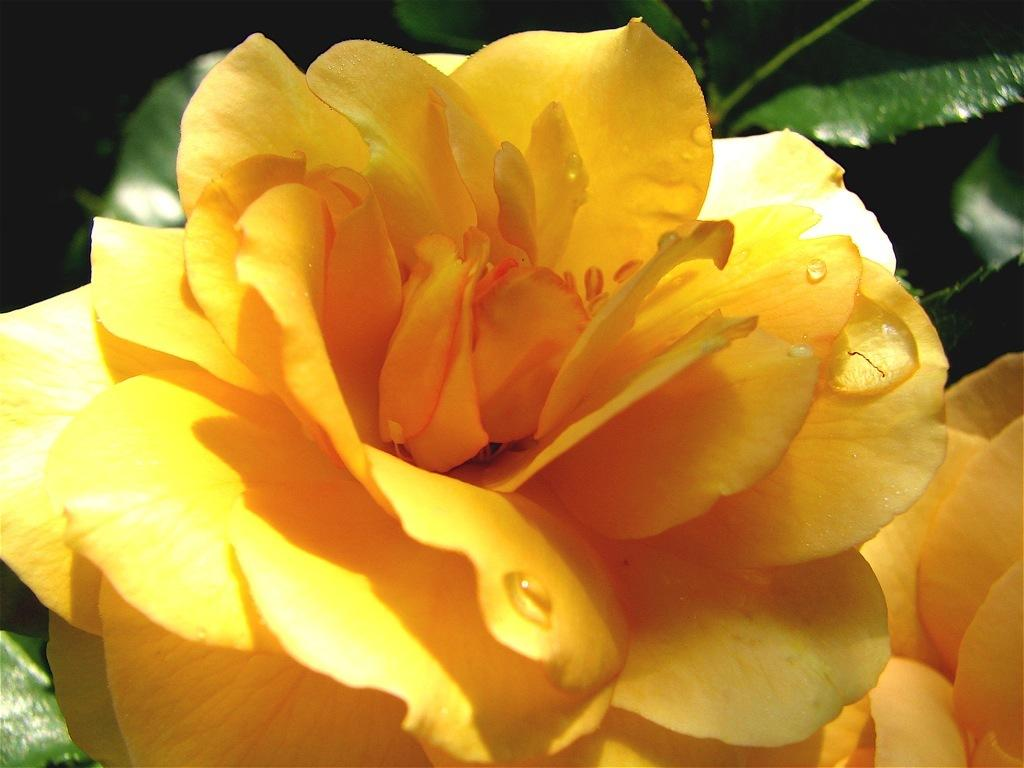What type of flower is in the image? There is a yellow rose flower in the image. What color are the leaves behind the flower? The leaves behind the flower are green. What type of dish is your dad preparing in the oven in the image? There is no dad, wave, or oven present in the image; it only features a yellow rose flower and green leaves. 